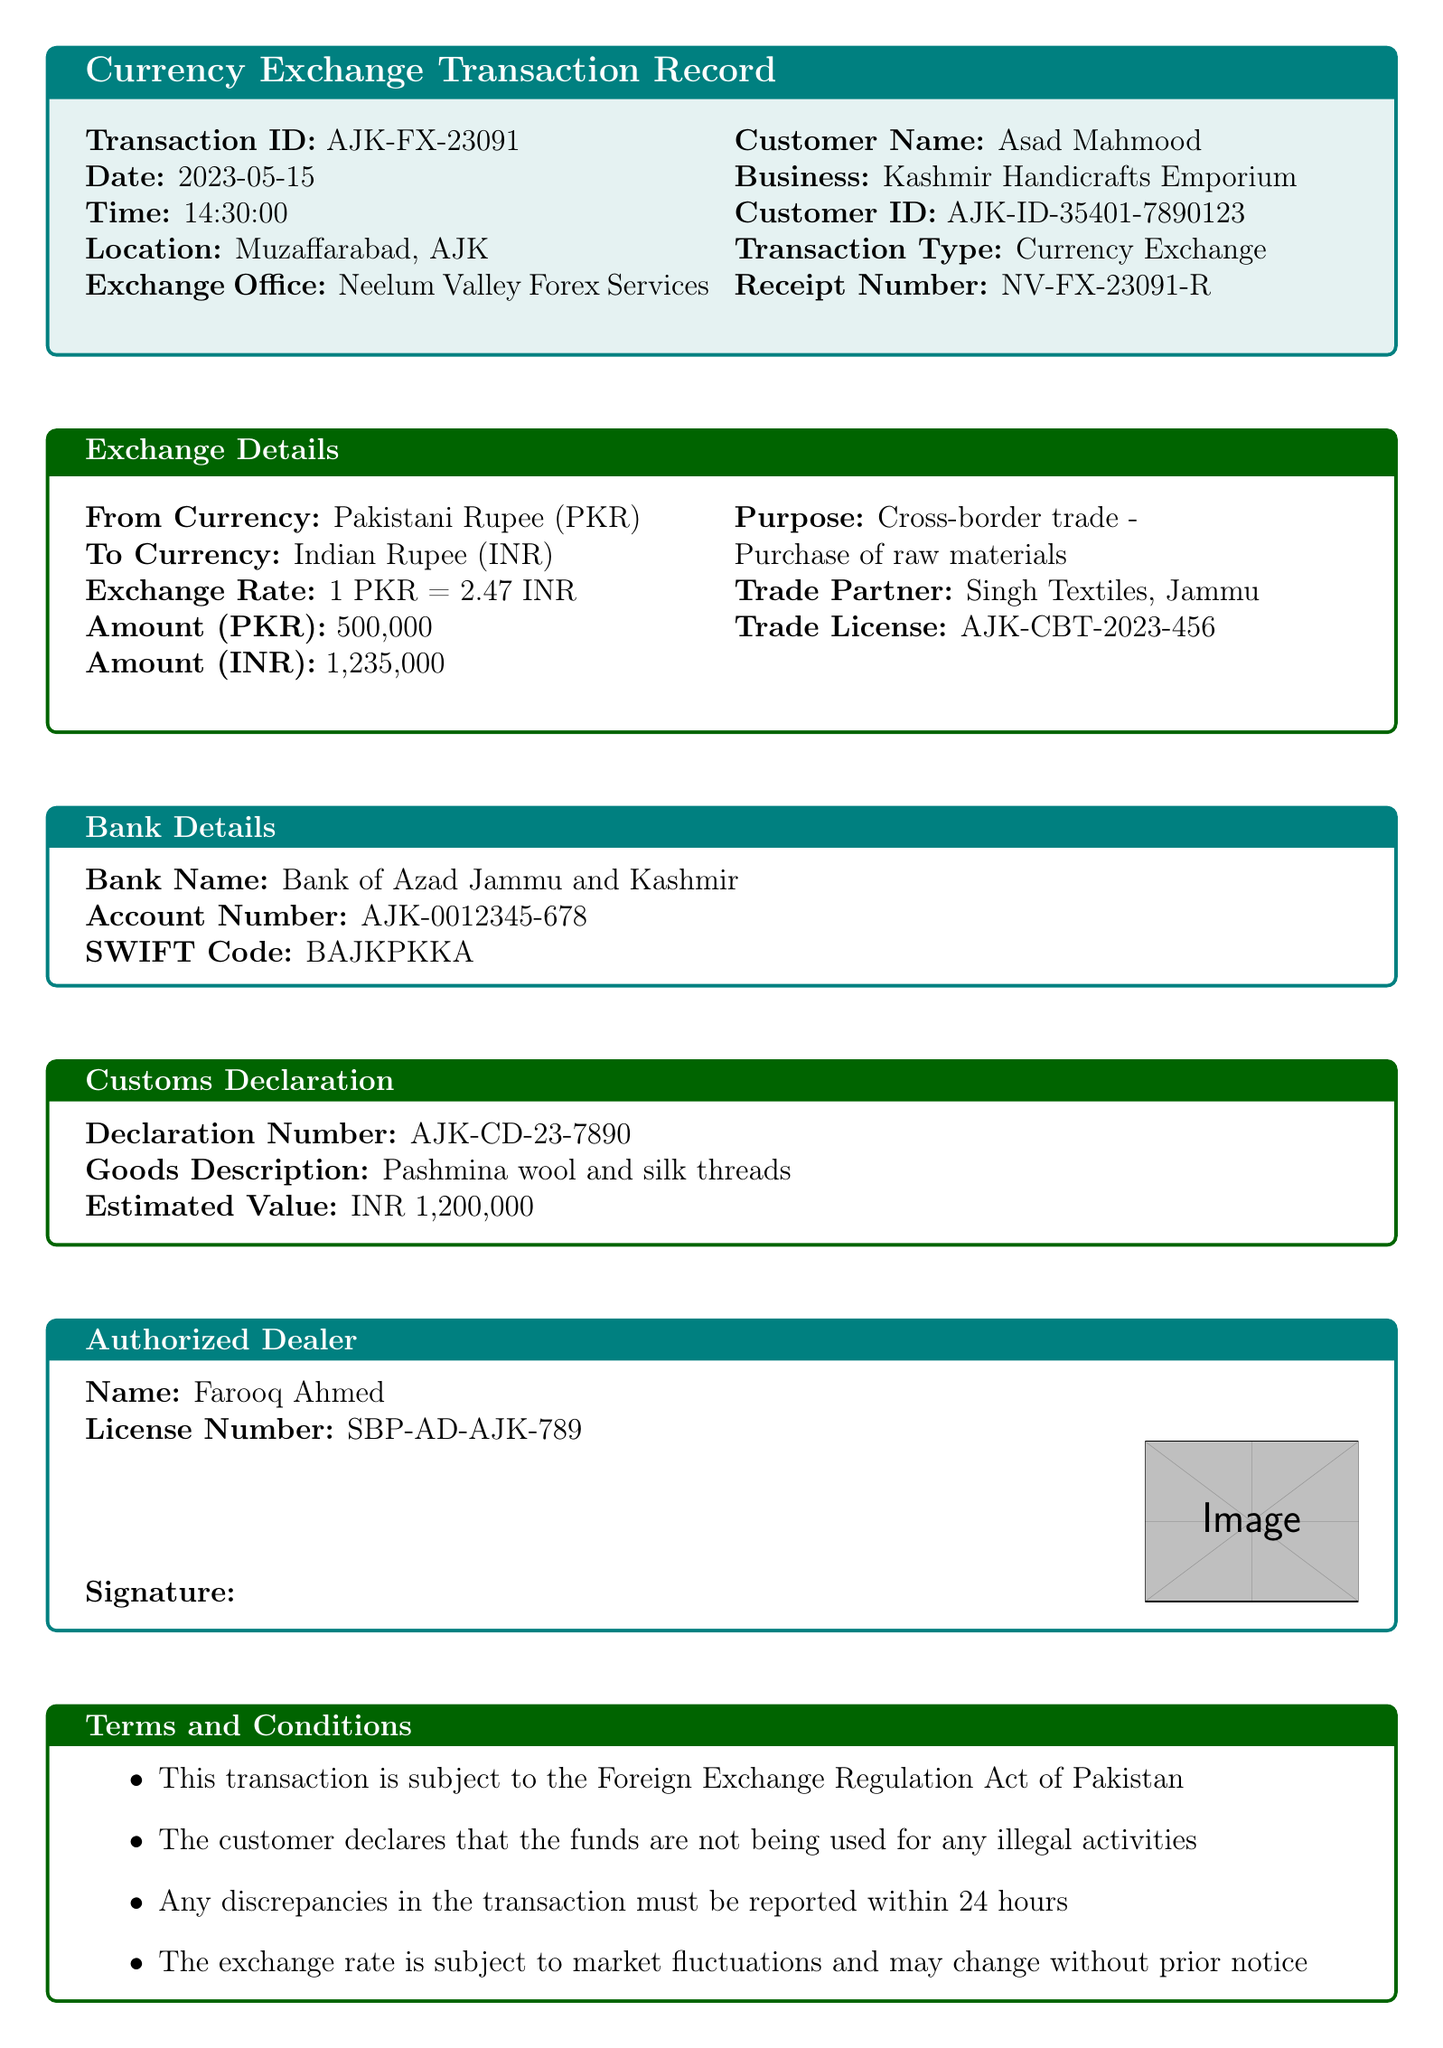What is the transaction ID? The transaction ID is a unique identifier for the currency exchange transaction found in the document under the Transaction ID section.
Answer: AJK-FX-23091 Who is the customer? The customer name is listed in the document, specifically highlighted under the Customer Name section.
Answer: Asad Mahmood What is the exchange rate? The exchange rate compares the value of Pakistani Rupees to Indian Rupees and is found under the Exchange Details section.
Answer: 2.47 What is the purpose of the transaction? The purpose of the transaction is stated in the document as it relates to the nature of the exchange, found in the Exchange Details section.
Answer: Cross-border trade - Purchase of raw materials What goods are described in the customs declaration? The goods description is specified in the Customs Declaration section and highlights the items involved in the trade.
Answer: Pashmina wool and silk threads What is the amount in Indian Rupees? The amount converted into Indian Rupees is detailed under the Exchange Details section, specifying how much was exchanged.
Answer: 1,235,000 Who approved the transaction? The name of the authorized dealer who approved the transaction is provided in the Authorized Dealer section of the document.
Answer: Farooq Ahmed What is the reception number? The receipt number serves as a reference for the transaction and is located at the end of the document.
Answer: NV-FX-23091-R What bank was used for the transaction? The bank name is part of the Bank Details section which specifies where the funds were handled.
Answer: Bank of Azad Jammu and Kashmir 